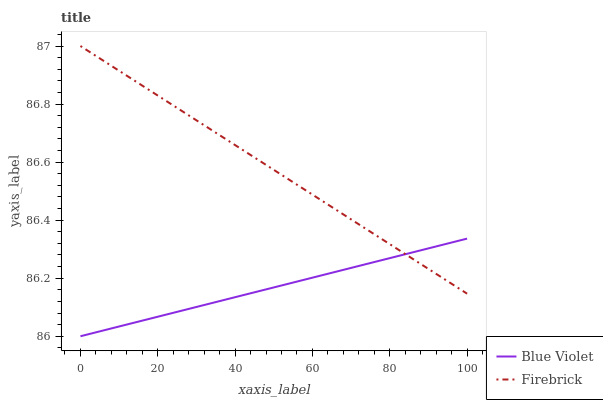Does Blue Violet have the minimum area under the curve?
Answer yes or no. Yes. Does Firebrick have the maximum area under the curve?
Answer yes or no. Yes. Does Blue Violet have the maximum area under the curve?
Answer yes or no. No. Is Firebrick the smoothest?
Answer yes or no. Yes. Is Blue Violet the roughest?
Answer yes or no. Yes. Is Blue Violet the smoothest?
Answer yes or no. No. Does Firebrick have the highest value?
Answer yes or no. Yes. Does Blue Violet have the highest value?
Answer yes or no. No. Does Blue Violet intersect Firebrick?
Answer yes or no. Yes. Is Blue Violet less than Firebrick?
Answer yes or no. No. Is Blue Violet greater than Firebrick?
Answer yes or no. No. 